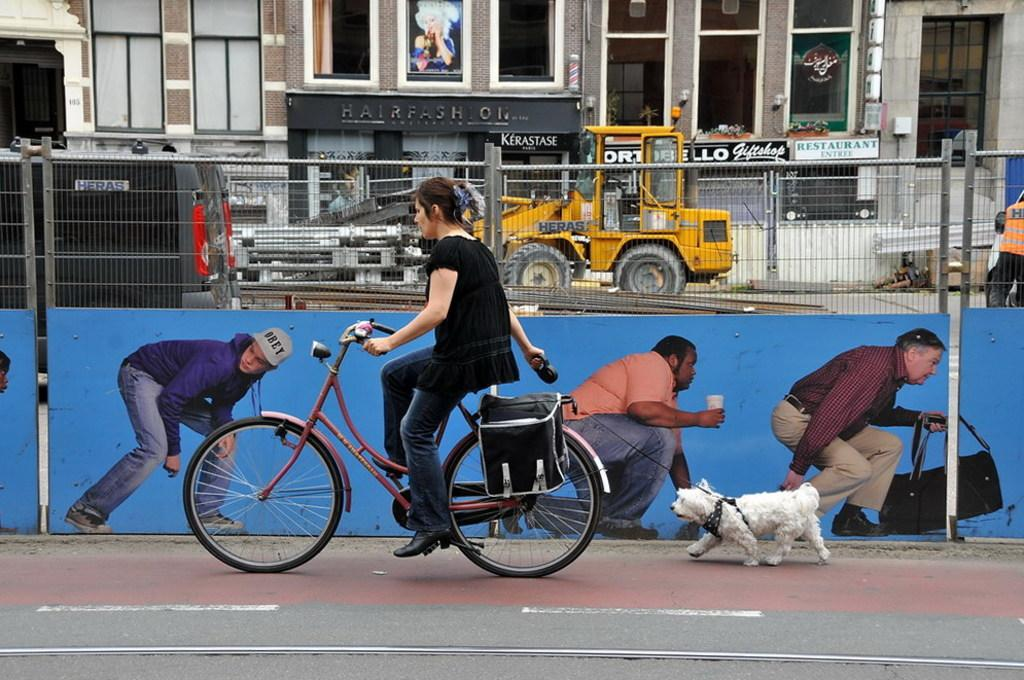Who is the main subject in the image? There is a woman in the image. What is the woman doing in the image? The woman is riding a cycle and holding a dog. What can be seen in the background of the image? There is a building named "fashion" and vehicles visible in the background. What type of bomb can be seen in the image? There is no bomb present in the image. The image features a dog being held by a woman riding a cycle, a building named "fashion" in the background, and vehicles visible in the background. There is no bomb present in the image. 